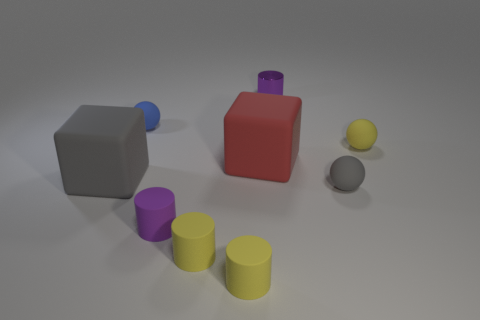Subtract all gray spheres. How many spheres are left? 2 Subtract 1 cubes. How many cubes are left? 1 Add 1 purple metal objects. How many objects exist? 10 Subtract all purple cylinders. How many cylinders are left? 2 Subtract all cubes. How many objects are left? 7 Subtract all red blocks. Subtract all brown cylinders. How many blocks are left? 1 Subtract all yellow spheres. How many green cubes are left? 0 Subtract all tiny matte spheres. Subtract all large red things. How many objects are left? 5 Add 9 gray matte blocks. How many gray matte blocks are left? 10 Add 6 small red shiny spheres. How many small red shiny spheres exist? 6 